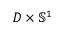<formula> <loc_0><loc_0><loc_500><loc_500>D \times \mathbb { S } ^ { 1 }</formula> 